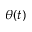Convert formula to latex. <formula><loc_0><loc_0><loc_500><loc_500>\theta ( t )</formula> 